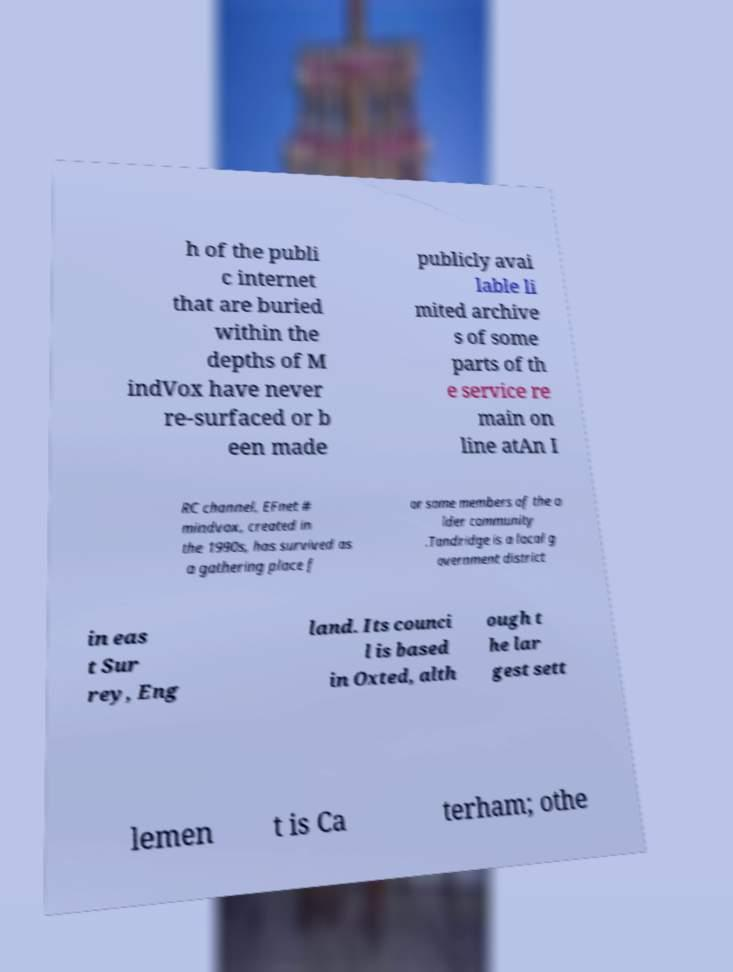Could you assist in decoding the text presented in this image and type it out clearly? h of the publi c internet that are buried within the depths of M indVox have never re-surfaced or b een made publicly avai lable li mited archive s of some parts of th e service re main on line atAn I RC channel, EFnet # mindvox, created in the 1990s, has survived as a gathering place f or some members of the o lder community .Tandridge is a local g overnment district in eas t Sur rey, Eng land. Its counci l is based in Oxted, alth ough t he lar gest sett lemen t is Ca terham; othe 